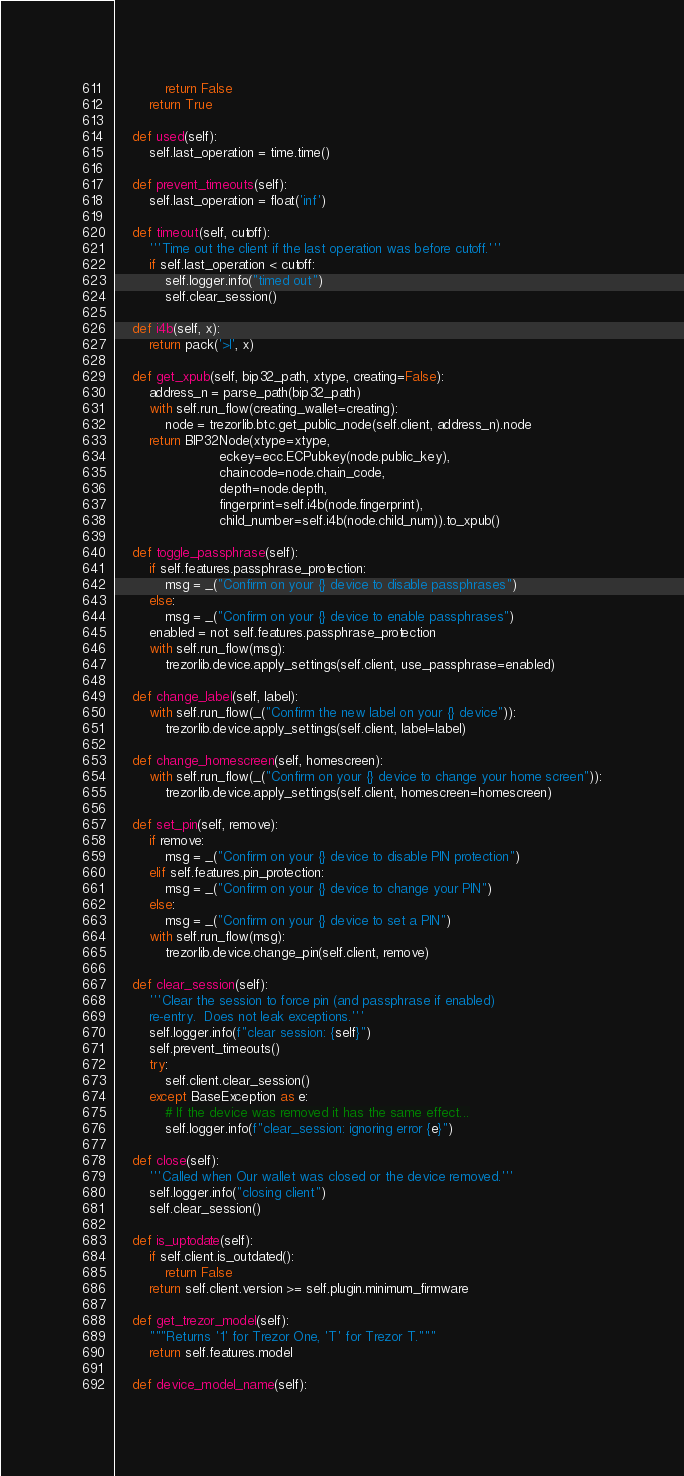<code> <loc_0><loc_0><loc_500><loc_500><_Python_>            return False
        return True

    def used(self):
        self.last_operation = time.time()

    def prevent_timeouts(self):
        self.last_operation = float('inf')

    def timeout(self, cutoff):
        '''Time out the client if the last operation was before cutoff.'''
        if self.last_operation < cutoff:
            self.logger.info("timed out")
            self.clear_session()

    def i4b(self, x):
        return pack('>I', x)

    def get_xpub(self, bip32_path, xtype, creating=False):
        address_n = parse_path(bip32_path)
        with self.run_flow(creating_wallet=creating):
            node = trezorlib.btc.get_public_node(self.client, address_n).node
        return BIP32Node(xtype=xtype,
                         eckey=ecc.ECPubkey(node.public_key),
                         chaincode=node.chain_code,
                         depth=node.depth,
                         fingerprint=self.i4b(node.fingerprint),
                         child_number=self.i4b(node.child_num)).to_xpub()

    def toggle_passphrase(self):
        if self.features.passphrase_protection:
            msg = _("Confirm on your {} device to disable passphrases")
        else:
            msg = _("Confirm on your {} device to enable passphrases")
        enabled = not self.features.passphrase_protection
        with self.run_flow(msg):
            trezorlib.device.apply_settings(self.client, use_passphrase=enabled)

    def change_label(self, label):
        with self.run_flow(_("Confirm the new label on your {} device")):
            trezorlib.device.apply_settings(self.client, label=label)

    def change_homescreen(self, homescreen):
        with self.run_flow(_("Confirm on your {} device to change your home screen")):
            trezorlib.device.apply_settings(self.client, homescreen=homescreen)

    def set_pin(self, remove):
        if remove:
            msg = _("Confirm on your {} device to disable PIN protection")
        elif self.features.pin_protection:
            msg = _("Confirm on your {} device to change your PIN")
        else:
            msg = _("Confirm on your {} device to set a PIN")
        with self.run_flow(msg):
            trezorlib.device.change_pin(self.client, remove)

    def clear_session(self):
        '''Clear the session to force pin (and passphrase if enabled)
        re-entry.  Does not leak exceptions.'''
        self.logger.info(f"clear session: {self}")
        self.prevent_timeouts()
        try:
            self.client.clear_session()
        except BaseException as e:
            # If the device was removed it has the same effect...
            self.logger.info(f"clear_session: ignoring error {e}")

    def close(self):
        '''Called when Our wallet was closed or the device removed.'''
        self.logger.info("closing client")
        self.clear_session()

    def is_uptodate(self):
        if self.client.is_outdated():
            return False
        return self.client.version >= self.plugin.minimum_firmware

    def get_trezor_model(self):
        """Returns '1' for Trezor One, 'T' for Trezor T."""
        return self.features.model

    def device_model_name(self):</code> 